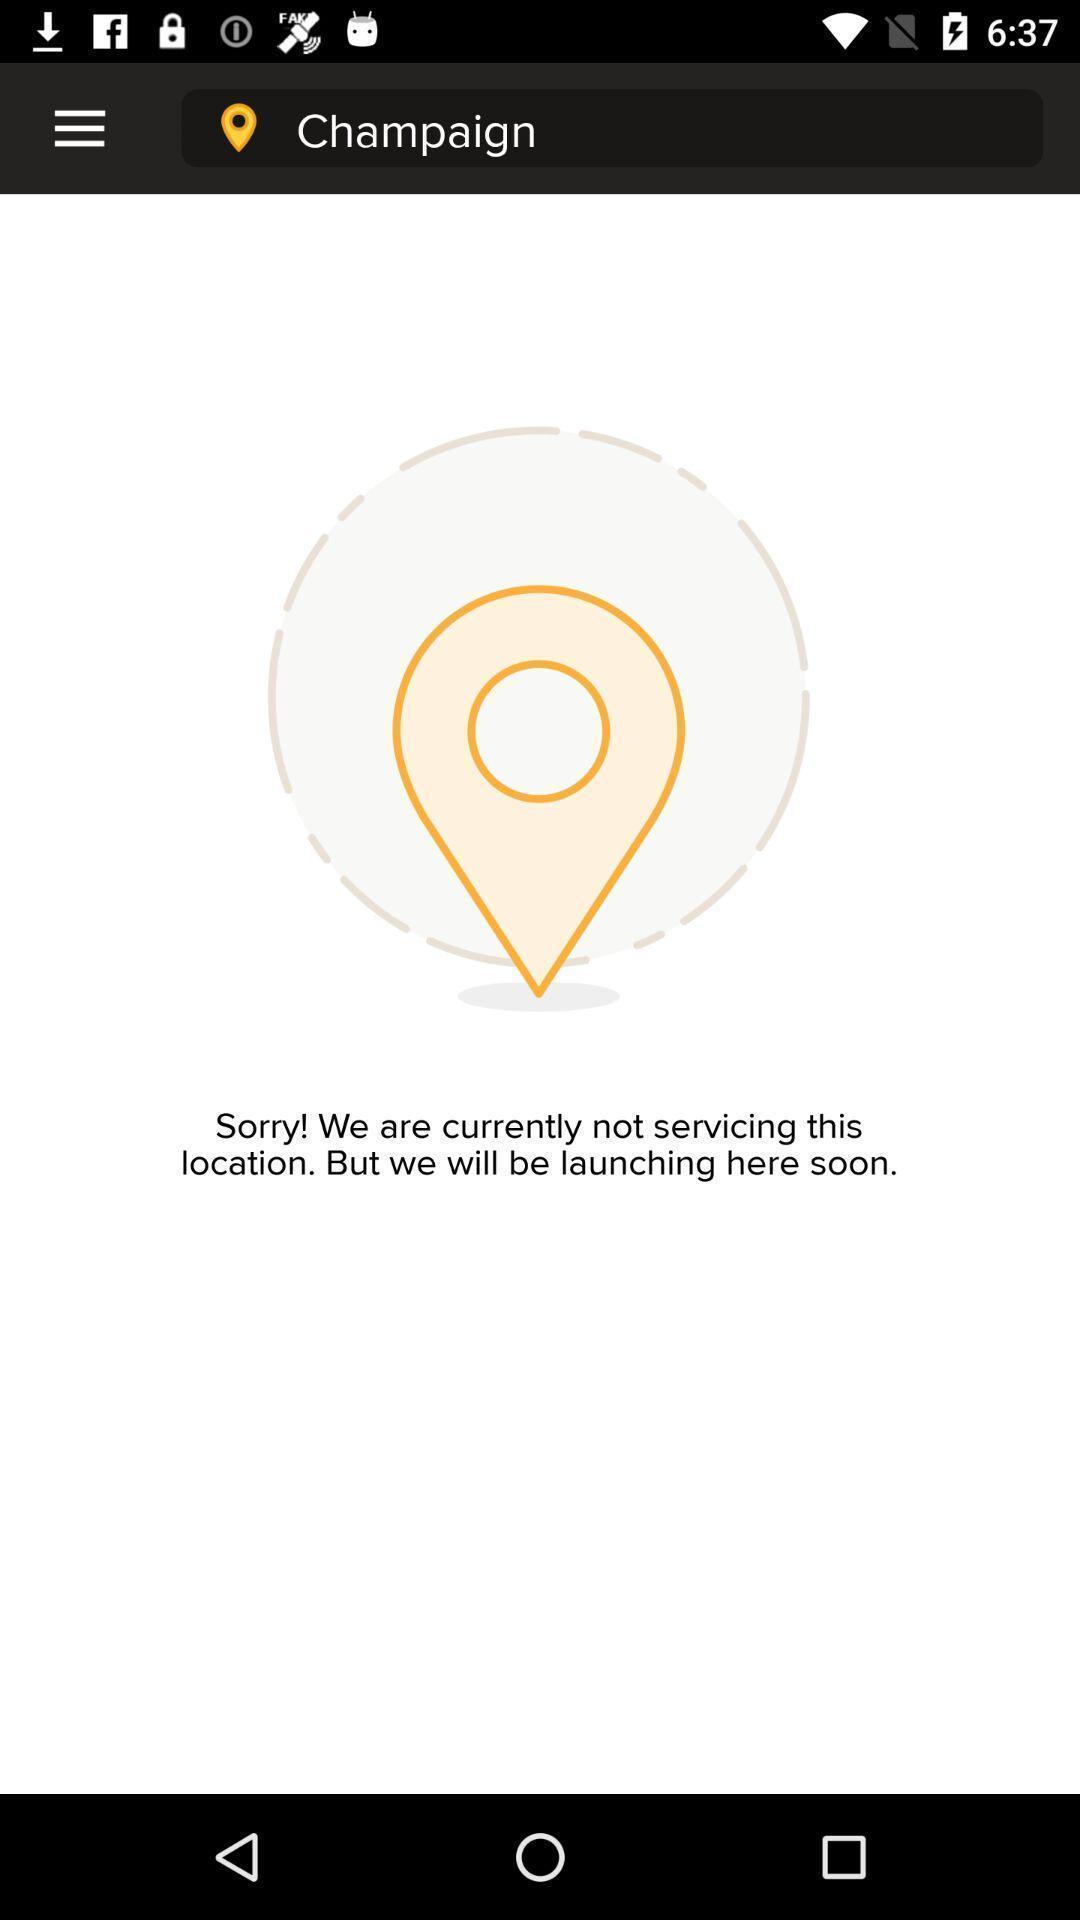Explain the elements present in this screenshot. Screen showing pin on selected location. 